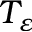Convert formula to latex. <formula><loc_0><loc_0><loc_500><loc_500>T _ { \varepsilon }</formula> 